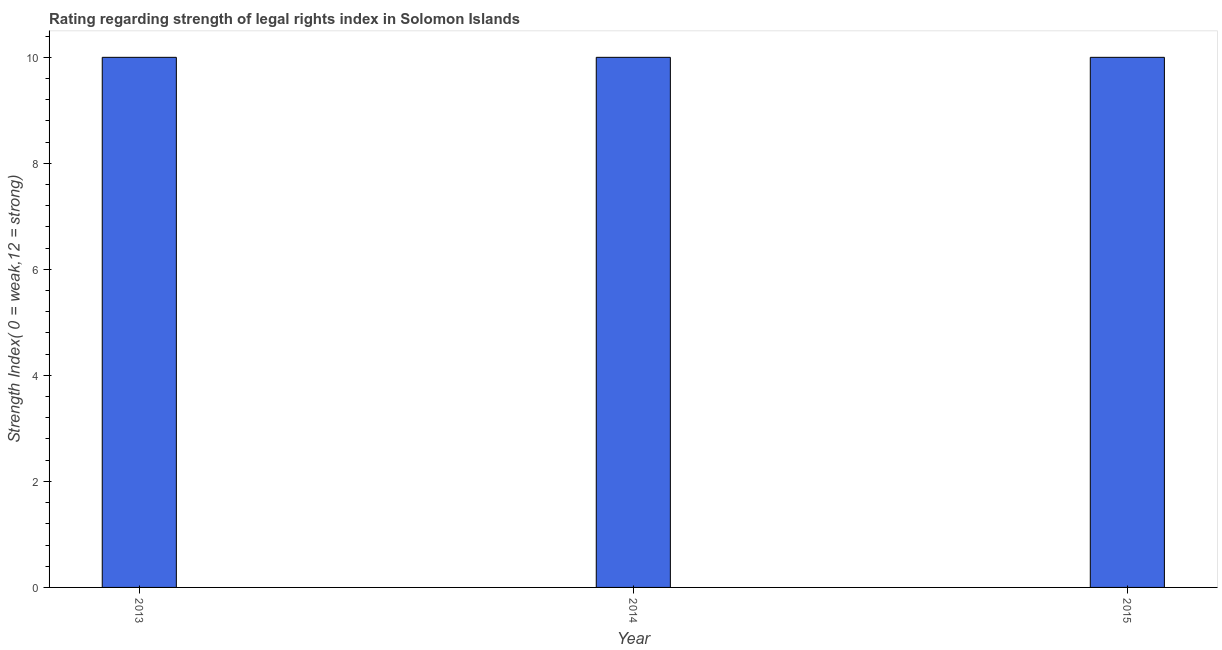What is the title of the graph?
Offer a terse response. Rating regarding strength of legal rights index in Solomon Islands. What is the label or title of the Y-axis?
Make the answer very short. Strength Index( 0 = weak,12 = strong). What is the strength of legal rights index in 2014?
Make the answer very short. 10. Across all years, what is the minimum strength of legal rights index?
Your answer should be very brief. 10. In which year was the strength of legal rights index minimum?
Give a very brief answer. 2013. What is the sum of the strength of legal rights index?
Your answer should be compact. 30. What is the difference between the strength of legal rights index in 2013 and 2014?
Provide a short and direct response. 0. In how many years, is the strength of legal rights index greater than 4.4 ?
Offer a very short reply. 3. Do a majority of the years between 2015 and 2014 (inclusive) have strength of legal rights index greater than 6.8 ?
Ensure brevity in your answer.  No. Is the difference between the strength of legal rights index in 2013 and 2014 greater than the difference between any two years?
Your answer should be very brief. Yes. In how many years, is the strength of legal rights index greater than the average strength of legal rights index taken over all years?
Your answer should be compact. 0. How many bars are there?
Offer a terse response. 3. What is the Strength Index( 0 = weak,12 = strong) of 2013?
Your response must be concise. 10. What is the Strength Index( 0 = weak,12 = strong) of 2015?
Provide a succinct answer. 10. What is the difference between the Strength Index( 0 = weak,12 = strong) in 2014 and 2015?
Provide a short and direct response. 0. What is the ratio of the Strength Index( 0 = weak,12 = strong) in 2013 to that in 2015?
Provide a succinct answer. 1. What is the ratio of the Strength Index( 0 = weak,12 = strong) in 2014 to that in 2015?
Provide a short and direct response. 1. 